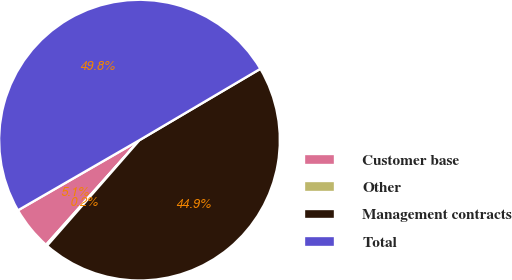Convert chart to OTSL. <chart><loc_0><loc_0><loc_500><loc_500><pie_chart><fcel>Customer base<fcel>Other<fcel>Management contracts<fcel>Total<nl><fcel>5.07%<fcel>0.15%<fcel>44.93%<fcel>49.85%<nl></chart> 